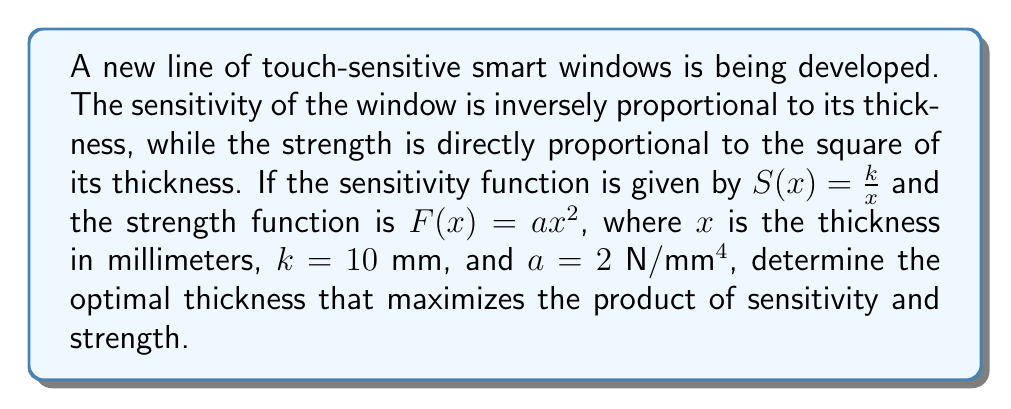Teach me how to tackle this problem. To find the optimal thickness, we need to maximize the product of sensitivity and strength. Let's call this product function $P(x)$.

1) First, we define the product function:
   $$P(x) = S(x) \cdot F(x) = \frac{k}{x} \cdot ax^2 = kax$$

2) Substituting the given values:
   $$P(x) = 10 \cdot 2 \cdot x = 20x$$

3) To find the maximum value of this function, we need to consider the constraints. The thickness cannot be zero or negative, and it has a practical upper limit. Let's assume the maximum practical thickness is 10 mm.

4) Since $P(x)$ is a linear function and positive for $x > 0$, it will reach its maximum value at the upper limit of the domain.

5) Therefore, the optimal thickness that maximizes the product of sensitivity and strength is 10 mm.

6) We can verify this by calculating $P(x)$ at different points:
   For $x = 5$ mm: $P(5) = 20 \cdot 5 = 100$
   For $x = 10$ mm: $P(10) = 20 \cdot 10 = 200$

This confirms that the product increases as thickness increases, reaching its maximum at the upper limit of 10 mm.
Answer: The optimal thickness for maximum product of sensitivity and strength is 10 mm. 